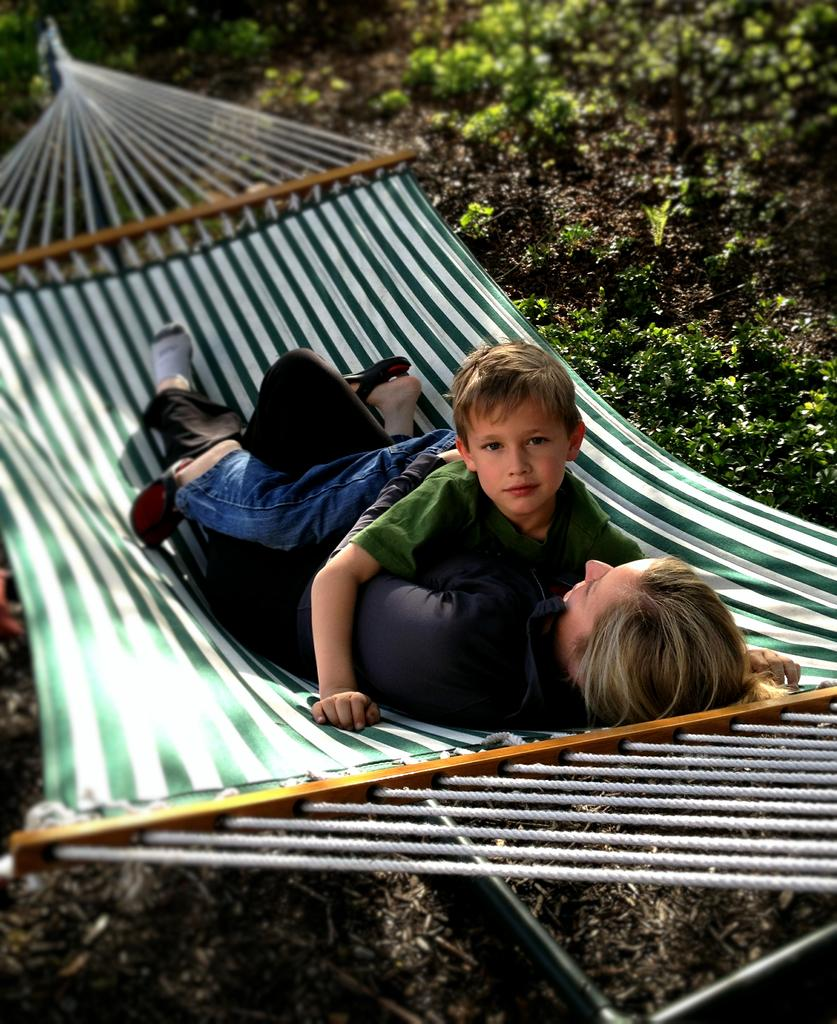Where was the image taken? The image was taken outside. Who is present in the image? There is a person and a kid in the image. What activity is the person and kid engaged in? It appears to be a swing in the image. What can be seen on the right side of the image? There are plants on the right side of the image. What type of suit is the person wearing in the image? There is no mention of a suit in the image; the person is not wearing any clothing mentioned in the facts. 